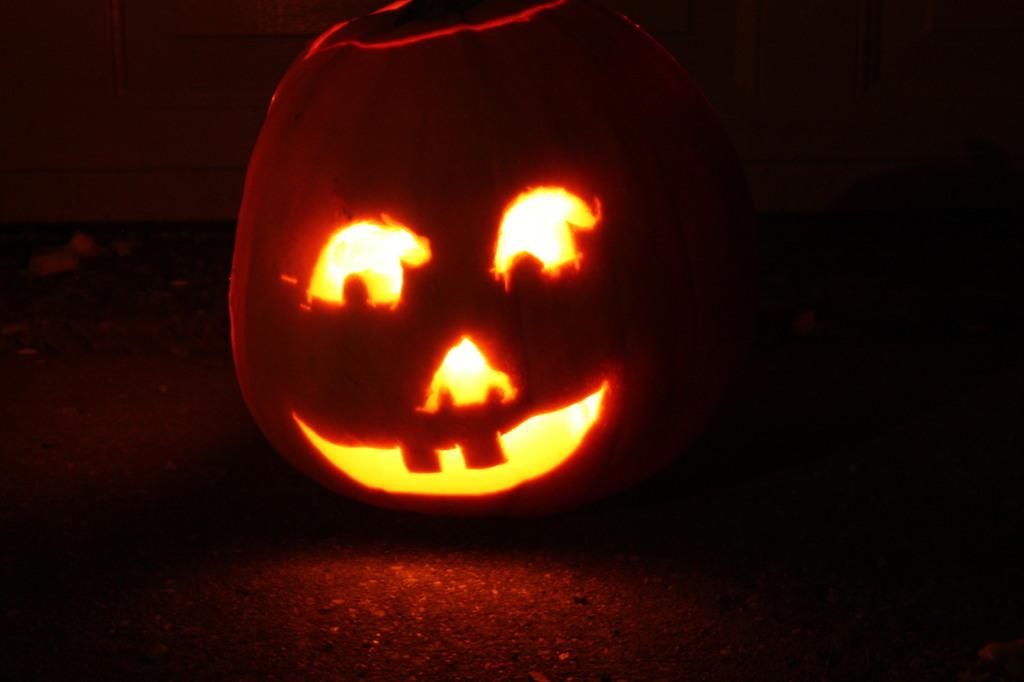What is the main object in the image? There is a pumpkin in the image. What is unique about the pumpkin? The pumpkin has a light inside it and is cut in the shape of a person's face. Where is the pumpkin located in the image? The pumpkin is placed on the floor. How would you describe the background of the image? The background of the image is dark in color. What holiday is being celebrated in the image? There is no specific holiday mentioned or depicted in the image. Can you provide an example of another object that could be used for the same purpose as the pumpkin in the image? It is difficult to provide an example of another object for the same purpose without knowing the context or purpose of the pumpkin in the image. --- Facts: 1. There is a person holding a book in the image. 2. The person is sitting on a chair. 3. The chair is made of wood. 4. The book has a blue cover. 5. The background of the image is a bookshelf. Absurd Topics: ocean, dance, animal Conversation: What is the person in the image doing? The person is holding a book in the image. Where is the person sitting? The person is sitting on a chair. What is the chair made of? The chair is made of wood. What color is the book's cover? The book has a blue cover. What can be seen in the background of the image? The background of the image is a bookshelf. Reasoning: Let's think step by step in order to produce the conversation. We start by identifying the main action of the person in the image, which is holding a book. Then, we describe the person's location and the material of the chair. Next, we mention the color of the book's cover. Finally, we describe the background of the image, which is a bookshelf. Absurd Question/Answer: Can you see any ocean waves in the image? No, there are no ocean waves present in the image. Is the person in the image dancing? No, the person is not dancing in the image; they are sitting and holding a book. 